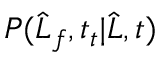<formula> <loc_0><loc_0><loc_500><loc_500>P ( \widehat { L } _ { f } , t _ { t } | \widehat { L } , t )</formula> 